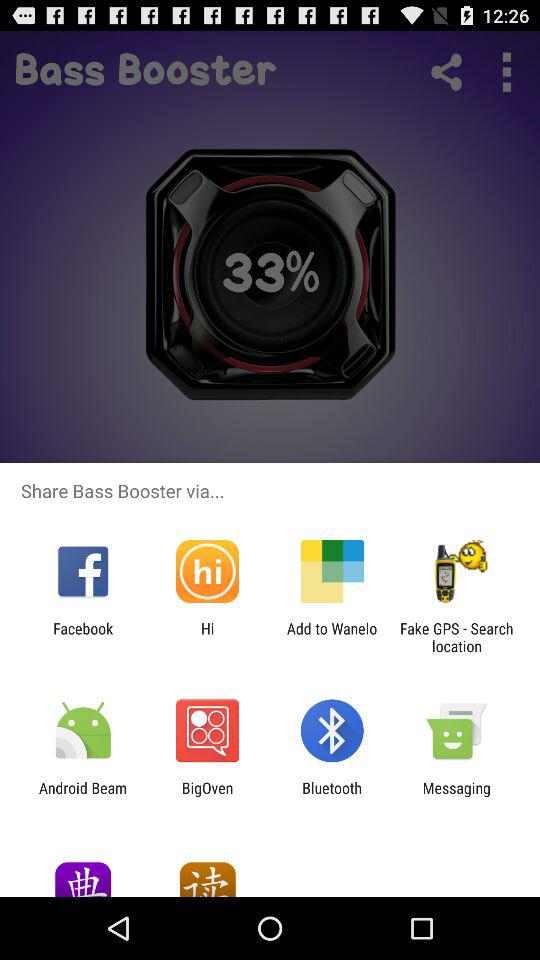Which devices can "Bass Booster" be connected to?
When the provided information is insufficient, respond with <no answer>. <no answer> 